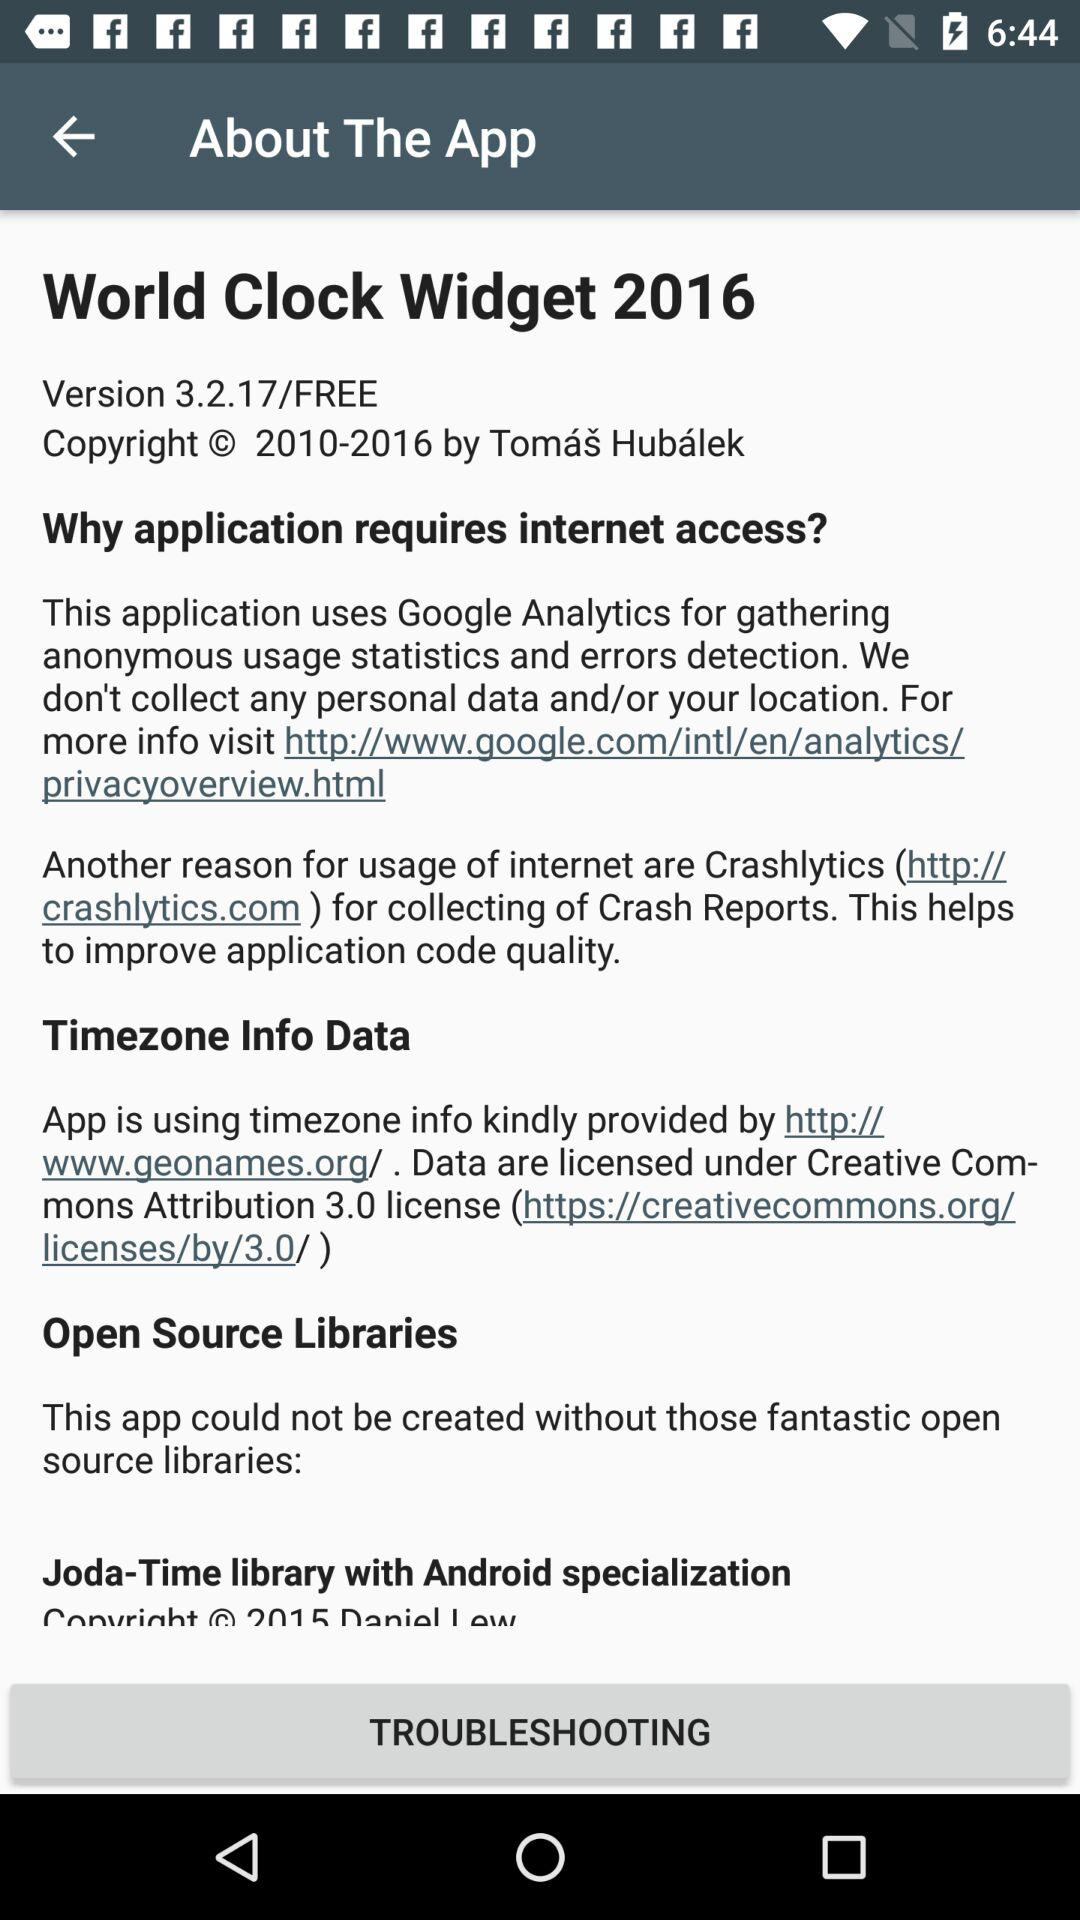What is the version of the app? The version is 3.2.17. 